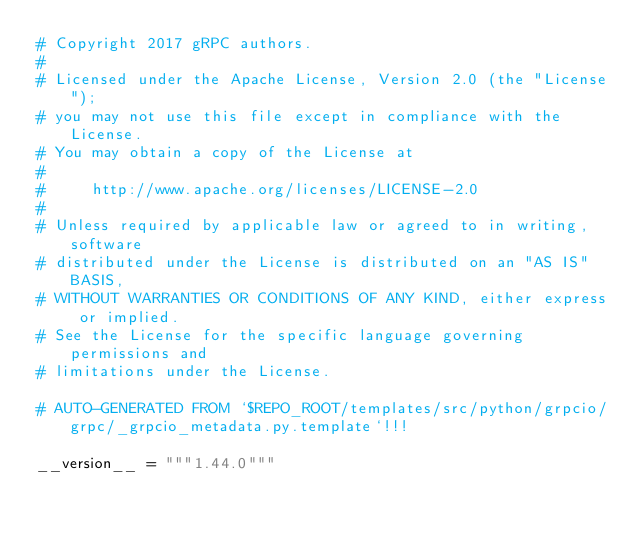<code> <loc_0><loc_0><loc_500><loc_500><_Python_># Copyright 2017 gRPC authors.
#
# Licensed under the Apache License, Version 2.0 (the "License");
# you may not use this file except in compliance with the License.
# You may obtain a copy of the License at
#
#     http://www.apache.org/licenses/LICENSE-2.0
#
# Unless required by applicable law or agreed to in writing, software
# distributed under the License is distributed on an "AS IS" BASIS,
# WITHOUT WARRANTIES OR CONDITIONS OF ANY KIND, either express or implied.
# See the License for the specific language governing permissions and
# limitations under the License.

# AUTO-GENERATED FROM `$REPO_ROOT/templates/src/python/grpcio/grpc/_grpcio_metadata.py.template`!!!

__version__ = """1.44.0"""
</code> 